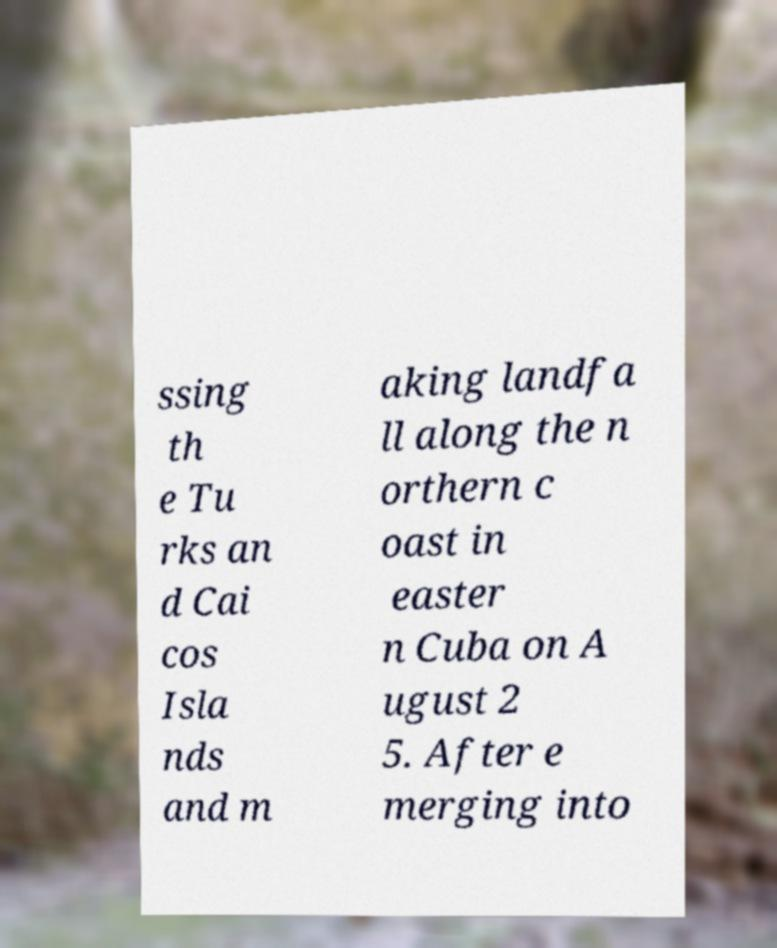Could you assist in decoding the text presented in this image and type it out clearly? ssing th e Tu rks an d Cai cos Isla nds and m aking landfa ll along the n orthern c oast in easter n Cuba on A ugust 2 5. After e merging into 